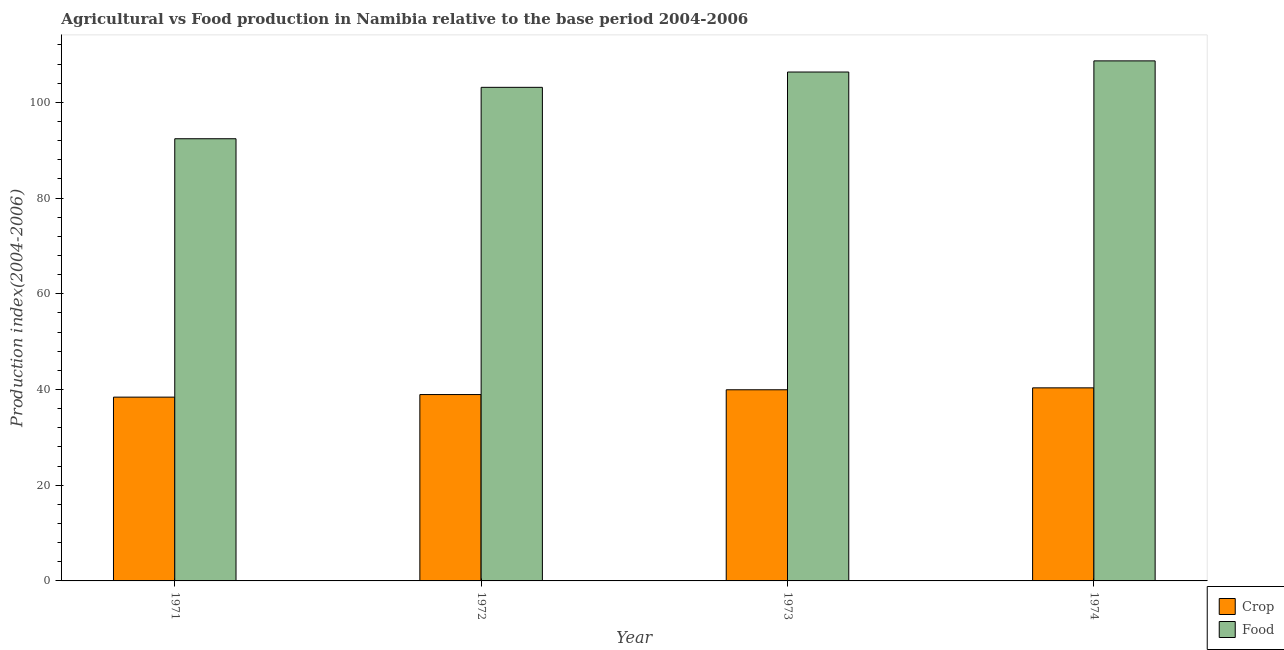How many different coloured bars are there?
Keep it short and to the point. 2. Are the number of bars on each tick of the X-axis equal?
Offer a very short reply. Yes. How many bars are there on the 3rd tick from the left?
Keep it short and to the point. 2. What is the label of the 4th group of bars from the left?
Ensure brevity in your answer.  1974. What is the food production index in 1971?
Provide a short and direct response. 92.39. Across all years, what is the maximum food production index?
Provide a succinct answer. 108.66. Across all years, what is the minimum crop production index?
Provide a succinct answer. 38.4. In which year was the food production index maximum?
Your response must be concise. 1974. What is the total food production index in the graph?
Your response must be concise. 410.51. What is the difference between the food production index in 1972 and that in 1973?
Keep it short and to the point. -3.2. What is the difference between the crop production index in 1973 and the food production index in 1974?
Your answer should be very brief. -0.4. What is the average crop production index per year?
Ensure brevity in your answer.  39.41. What is the ratio of the food production index in 1972 to that in 1974?
Provide a succinct answer. 0.95. Is the difference between the food production index in 1971 and 1972 greater than the difference between the crop production index in 1971 and 1972?
Provide a short and direct response. No. What is the difference between the highest and the second highest crop production index?
Offer a very short reply. 0.4. What is the difference between the highest and the lowest food production index?
Ensure brevity in your answer.  16.27. What does the 1st bar from the left in 1972 represents?
Your answer should be very brief. Crop. What does the 1st bar from the right in 1971 represents?
Offer a terse response. Food. Are all the bars in the graph horizontal?
Your answer should be very brief. No. How many years are there in the graph?
Your answer should be very brief. 4. What is the difference between two consecutive major ticks on the Y-axis?
Your answer should be very brief. 20. Are the values on the major ticks of Y-axis written in scientific E-notation?
Offer a very short reply. No. Where does the legend appear in the graph?
Offer a terse response. Bottom right. What is the title of the graph?
Make the answer very short. Agricultural vs Food production in Namibia relative to the base period 2004-2006. Does "Register a property" appear as one of the legend labels in the graph?
Give a very brief answer. No. What is the label or title of the X-axis?
Your response must be concise. Year. What is the label or title of the Y-axis?
Keep it short and to the point. Production index(2004-2006). What is the Production index(2004-2006) of Crop in 1971?
Your response must be concise. 38.4. What is the Production index(2004-2006) in Food in 1971?
Give a very brief answer. 92.39. What is the Production index(2004-2006) in Crop in 1972?
Make the answer very short. 38.94. What is the Production index(2004-2006) of Food in 1972?
Offer a terse response. 103.13. What is the Production index(2004-2006) of Crop in 1973?
Provide a succinct answer. 39.94. What is the Production index(2004-2006) of Food in 1973?
Your answer should be compact. 106.33. What is the Production index(2004-2006) of Crop in 1974?
Give a very brief answer. 40.34. What is the Production index(2004-2006) in Food in 1974?
Ensure brevity in your answer.  108.66. Across all years, what is the maximum Production index(2004-2006) of Crop?
Make the answer very short. 40.34. Across all years, what is the maximum Production index(2004-2006) of Food?
Give a very brief answer. 108.66. Across all years, what is the minimum Production index(2004-2006) of Crop?
Your response must be concise. 38.4. Across all years, what is the minimum Production index(2004-2006) in Food?
Your answer should be very brief. 92.39. What is the total Production index(2004-2006) in Crop in the graph?
Your answer should be very brief. 157.62. What is the total Production index(2004-2006) in Food in the graph?
Ensure brevity in your answer.  410.51. What is the difference between the Production index(2004-2006) of Crop in 1971 and that in 1972?
Give a very brief answer. -0.54. What is the difference between the Production index(2004-2006) in Food in 1971 and that in 1972?
Your answer should be very brief. -10.74. What is the difference between the Production index(2004-2006) in Crop in 1971 and that in 1973?
Make the answer very short. -1.54. What is the difference between the Production index(2004-2006) in Food in 1971 and that in 1973?
Make the answer very short. -13.94. What is the difference between the Production index(2004-2006) of Crop in 1971 and that in 1974?
Keep it short and to the point. -1.94. What is the difference between the Production index(2004-2006) of Food in 1971 and that in 1974?
Give a very brief answer. -16.27. What is the difference between the Production index(2004-2006) in Crop in 1972 and that in 1974?
Provide a succinct answer. -1.4. What is the difference between the Production index(2004-2006) of Food in 1972 and that in 1974?
Offer a very short reply. -5.53. What is the difference between the Production index(2004-2006) of Crop in 1973 and that in 1974?
Keep it short and to the point. -0.4. What is the difference between the Production index(2004-2006) in Food in 1973 and that in 1974?
Ensure brevity in your answer.  -2.33. What is the difference between the Production index(2004-2006) in Crop in 1971 and the Production index(2004-2006) in Food in 1972?
Make the answer very short. -64.73. What is the difference between the Production index(2004-2006) in Crop in 1971 and the Production index(2004-2006) in Food in 1973?
Offer a very short reply. -67.93. What is the difference between the Production index(2004-2006) in Crop in 1971 and the Production index(2004-2006) in Food in 1974?
Provide a succinct answer. -70.26. What is the difference between the Production index(2004-2006) of Crop in 1972 and the Production index(2004-2006) of Food in 1973?
Ensure brevity in your answer.  -67.39. What is the difference between the Production index(2004-2006) in Crop in 1972 and the Production index(2004-2006) in Food in 1974?
Ensure brevity in your answer.  -69.72. What is the difference between the Production index(2004-2006) of Crop in 1973 and the Production index(2004-2006) of Food in 1974?
Provide a succinct answer. -68.72. What is the average Production index(2004-2006) of Crop per year?
Ensure brevity in your answer.  39.41. What is the average Production index(2004-2006) of Food per year?
Offer a terse response. 102.63. In the year 1971, what is the difference between the Production index(2004-2006) of Crop and Production index(2004-2006) of Food?
Give a very brief answer. -53.99. In the year 1972, what is the difference between the Production index(2004-2006) in Crop and Production index(2004-2006) in Food?
Offer a very short reply. -64.19. In the year 1973, what is the difference between the Production index(2004-2006) in Crop and Production index(2004-2006) in Food?
Your answer should be very brief. -66.39. In the year 1974, what is the difference between the Production index(2004-2006) of Crop and Production index(2004-2006) of Food?
Your response must be concise. -68.32. What is the ratio of the Production index(2004-2006) in Crop in 1971 to that in 1972?
Your response must be concise. 0.99. What is the ratio of the Production index(2004-2006) of Food in 1971 to that in 1972?
Keep it short and to the point. 0.9. What is the ratio of the Production index(2004-2006) in Crop in 1971 to that in 1973?
Keep it short and to the point. 0.96. What is the ratio of the Production index(2004-2006) of Food in 1971 to that in 1973?
Your answer should be very brief. 0.87. What is the ratio of the Production index(2004-2006) in Crop in 1971 to that in 1974?
Offer a terse response. 0.95. What is the ratio of the Production index(2004-2006) of Food in 1971 to that in 1974?
Ensure brevity in your answer.  0.85. What is the ratio of the Production index(2004-2006) of Food in 1972 to that in 1973?
Give a very brief answer. 0.97. What is the ratio of the Production index(2004-2006) of Crop in 1972 to that in 1974?
Make the answer very short. 0.97. What is the ratio of the Production index(2004-2006) in Food in 1972 to that in 1974?
Keep it short and to the point. 0.95. What is the ratio of the Production index(2004-2006) in Crop in 1973 to that in 1974?
Your answer should be very brief. 0.99. What is the ratio of the Production index(2004-2006) of Food in 1973 to that in 1974?
Make the answer very short. 0.98. What is the difference between the highest and the second highest Production index(2004-2006) of Food?
Offer a terse response. 2.33. What is the difference between the highest and the lowest Production index(2004-2006) in Crop?
Keep it short and to the point. 1.94. What is the difference between the highest and the lowest Production index(2004-2006) in Food?
Provide a succinct answer. 16.27. 